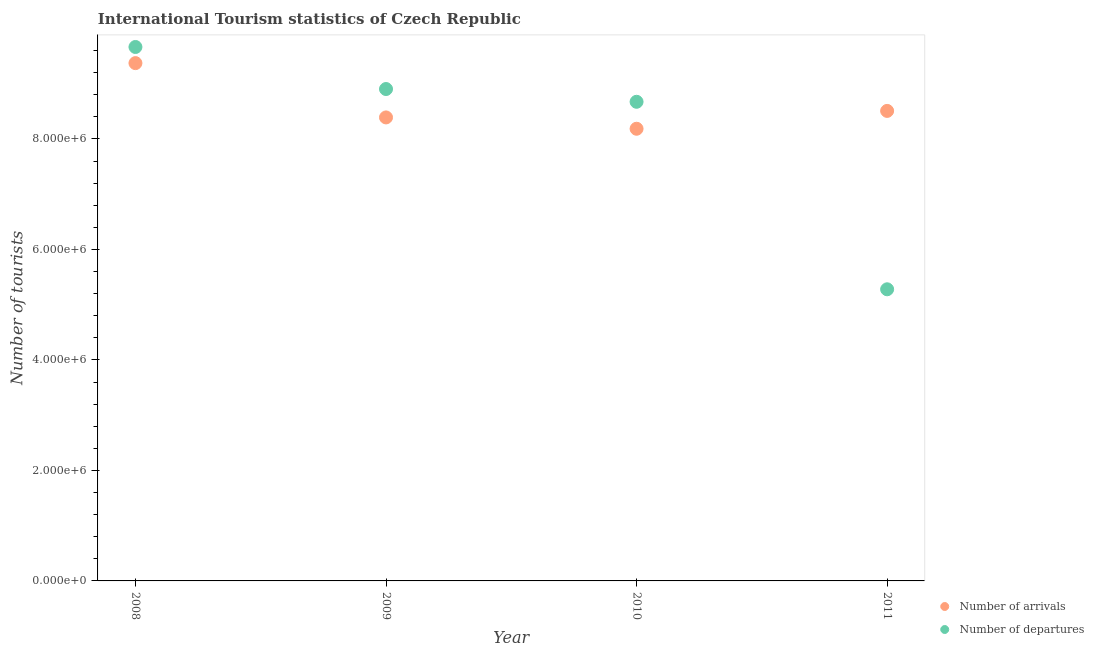Is the number of dotlines equal to the number of legend labels?
Provide a short and direct response. Yes. What is the number of tourist departures in 2010?
Your answer should be compact. 8.67e+06. Across all years, what is the maximum number of tourist departures?
Give a very brief answer. 9.66e+06. Across all years, what is the minimum number of tourist departures?
Make the answer very short. 5.28e+06. In which year was the number of tourist departures maximum?
Your answer should be compact. 2008. What is the total number of tourist departures in the graph?
Give a very brief answer. 3.25e+07. What is the difference between the number of tourist departures in 2008 and that in 2011?
Make the answer very short. 4.39e+06. What is the difference between the number of tourist departures in 2010 and the number of tourist arrivals in 2009?
Provide a short and direct response. 2.83e+05. What is the average number of tourist departures per year?
Offer a very short reply. 8.13e+06. In the year 2011, what is the difference between the number of tourist arrivals and number of tourist departures?
Make the answer very short. 3.23e+06. In how many years, is the number of tourist departures greater than 400000?
Your response must be concise. 4. What is the ratio of the number of tourist departures in 2010 to that in 2011?
Provide a succinct answer. 1.64. Is the number of tourist departures in 2010 less than that in 2011?
Provide a succinct answer. No. What is the difference between the highest and the second highest number of tourist arrivals?
Ensure brevity in your answer.  8.65e+05. What is the difference between the highest and the lowest number of tourist arrivals?
Offer a terse response. 1.19e+06. In how many years, is the number of tourist departures greater than the average number of tourist departures taken over all years?
Keep it short and to the point. 3. Does the number of tourist departures monotonically increase over the years?
Provide a succinct answer. No. Is the number of tourist departures strictly greater than the number of tourist arrivals over the years?
Keep it short and to the point. No. How many dotlines are there?
Offer a very short reply. 2. Does the graph contain any zero values?
Provide a succinct answer. No. Does the graph contain grids?
Ensure brevity in your answer.  No. Where does the legend appear in the graph?
Offer a terse response. Bottom right. What is the title of the graph?
Make the answer very short. International Tourism statistics of Czech Republic. What is the label or title of the X-axis?
Offer a terse response. Year. What is the label or title of the Y-axis?
Ensure brevity in your answer.  Number of tourists. What is the Number of tourists in Number of arrivals in 2008?
Provide a short and direct response. 9.37e+06. What is the Number of tourists of Number of departures in 2008?
Your answer should be very brief. 9.66e+06. What is the Number of tourists of Number of arrivals in 2009?
Give a very brief answer. 8.39e+06. What is the Number of tourists in Number of departures in 2009?
Give a very brief answer. 8.90e+06. What is the Number of tourists in Number of arrivals in 2010?
Keep it short and to the point. 8.18e+06. What is the Number of tourists of Number of departures in 2010?
Provide a succinct answer. 8.67e+06. What is the Number of tourists in Number of arrivals in 2011?
Your response must be concise. 8.51e+06. What is the Number of tourists of Number of departures in 2011?
Offer a terse response. 5.28e+06. Across all years, what is the maximum Number of tourists in Number of arrivals?
Keep it short and to the point. 9.37e+06. Across all years, what is the maximum Number of tourists in Number of departures?
Provide a short and direct response. 9.66e+06. Across all years, what is the minimum Number of tourists in Number of arrivals?
Your response must be concise. 8.18e+06. Across all years, what is the minimum Number of tourists of Number of departures?
Your answer should be compact. 5.28e+06. What is the total Number of tourists in Number of arrivals in the graph?
Your answer should be compact. 3.45e+07. What is the total Number of tourists in Number of departures in the graph?
Provide a succinct answer. 3.25e+07. What is the difference between the Number of tourists of Number of arrivals in 2008 and that in 2009?
Ensure brevity in your answer.  9.83e+05. What is the difference between the Number of tourists of Number of departures in 2008 and that in 2009?
Provide a succinct answer. 7.61e+05. What is the difference between the Number of tourists of Number of arrivals in 2008 and that in 2010?
Offer a terse response. 1.19e+06. What is the difference between the Number of tourists of Number of departures in 2008 and that in 2010?
Ensure brevity in your answer.  9.92e+05. What is the difference between the Number of tourists in Number of arrivals in 2008 and that in 2011?
Provide a succinct answer. 8.65e+05. What is the difference between the Number of tourists of Number of departures in 2008 and that in 2011?
Your response must be concise. 4.39e+06. What is the difference between the Number of tourists of Number of arrivals in 2009 and that in 2010?
Give a very brief answer. 2.05e+05. What is the difference between the Number of tourists in Number of departures in 2009 and that in 2010?
Provide a succinct answer. 2.31e+05. What is the difference between the Number of tourists in Number of arrivals in 2009 and that in 2011?
Keep it short and to the point. -1.18e+05. What is the difference between the Number of tourists of Number of departures in 2009 and that in 2011?
Your answer should be very brief. 3.62e+06. What is the difference between the Number of tourists in Number of arrivals in 2010 and that in 2011?
Keep it short and to the point. -3.23e+05. What is the difference between the Number of tourists of Number of departures in 2010 and that in 2011?
Provide a short and direct response. 3.39e+06. What is the difference between the Number of tourists of Number of arrivals in 2008 and the Number of tourists of Number of departures in 2009?
Give a very brief answer. 4.69e+05. What is the difference between the Number of tourists in Number of arrivals in 2008 and the Number of tourists in Number of departures in 2011?
Offer a terse response. 4.09e+06. What is the difference between the Number of tourists of Number of arrivals in 2009 and the Number of tourists of Number of departures in 2010?
Make the answer very short. -2.83e+05. What is the difference between the Number of tourists of Number of arrivals in 2009 and the Number of tourists of Number of departures in 2011?
Offer a very short reply. 3.11e+06. What is the difference between the Number of tourists in Number of arrivals in 2010 and the Number of tourists in Number of departures in 2011?
Your response must be concise. 2.91e+06. What is the average Number of tourists in Number of arrivals per year?
Make the answer very short. 8.61e+06. What is the average Number of tourists in Number of departures per year?
Give a very brief answer. 8.13e+06. In the year 2008, what is the difference between the Number of tourists of Number of arrivals and Number of tourists of Number of departures?
Provide a short and direct response. -2.92e+05. In the year 2009, what is the difference between the Number of tourists in Number of arrivals and Number of tourists in Number of departures?
Ensure brevity in your answer.  -5.14e+05. In the year 2010, what is the difference between the Number of tourists of Number of arrivals and Number of tourists of Number of departures?
Offer a very short reply. -4.88e+05. In the year 2011, what is the difference between the Number of tourists in Number of arrivals and Number of tourists in Number of departures?
Make the answer very short. 3.23e+06. What is the ratio of the Number of tourists in Number of arrivals in 2008 to that in 2009?
Your answer should be very brief. 1.12. What is the ratio of the Number of tourists of Number of departures in 2008 to that in 2009?
Your answer should be compact. 1.09. What is the ratio of the Number of tourists of Number of arrivals in 2008 to that in 2010?
Keep it short and to the point. 1.15. What is the ratio of the Number of tourists in Number of departures in 2008 to that in 2010?
Your response must be concise. 1.11. What is the ratio of the Number of tourists of Number of arrivals in 2008 to that in 2011?
Offer a very short reply. 1.1. What is the ratio of the Number of tourists of Number of departures in 2008 to that in 2011?
Keep it short and to the point. 1.83. What is the ratio of the Number of tourists in Number of departures in 2009 to that in 2010?
Keep it short and to the point. 1.03. What is the ratio of the Number of tourists in Number of arrivals in 2009 to that in 2011?
Offer a terse response. 0.99. What is the ratio of the Number of tourists in Number of departures in 2009 to that in 2011?
Provide a succinct answer. 1.69. What is the ratio of the Number of tourists of Number of departures in 2010 to that in 2011?
Offer a terse response. 1.64. What is the difference between the highest and the second highest Number of tourists of Number of arrivals?
Make the answer very short. 8.65e+05. What is the difference between the highest and the second highest Number of tourists of Number of departures?
Ensure brevity in your answer.  7.61e+05. What is the difference between the highest and the lowest Number of tourists of Number of arrivals?
Make the answer very short. 1.19e+06. What is the difference between the highest and the lowest Number of tourists in Number of departures?
Your response must be concise. 4.39e+06. 